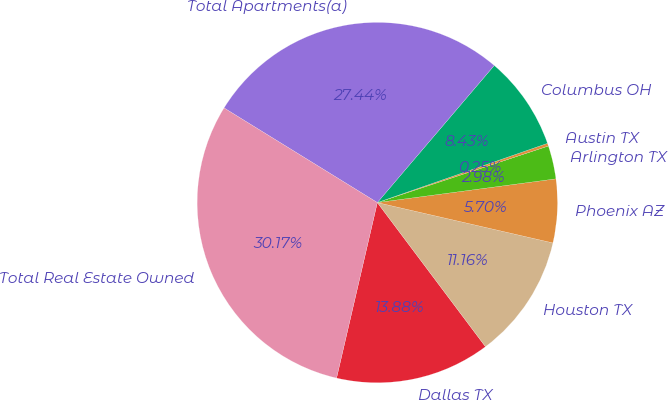<chart> <loc_0><loc_0><loc_500><loc_500><pie_chart><fcel>Dallas TX<fcel>Houston TX<fcel>Phoenix AZ<fcel>Arlington TX<fcel>Austin TX<fcel>Columbus OH<fcel>Total Apartments(a)<fcel>Total Real Estate Owned<nl><fcel>13.88%<fcel>11.16%<fcel>5.7%<fcel>2.98%<fcel>0.25%<fcel>8.43%<fcel>27.44%<fcel>30.17%<nl></chart> 